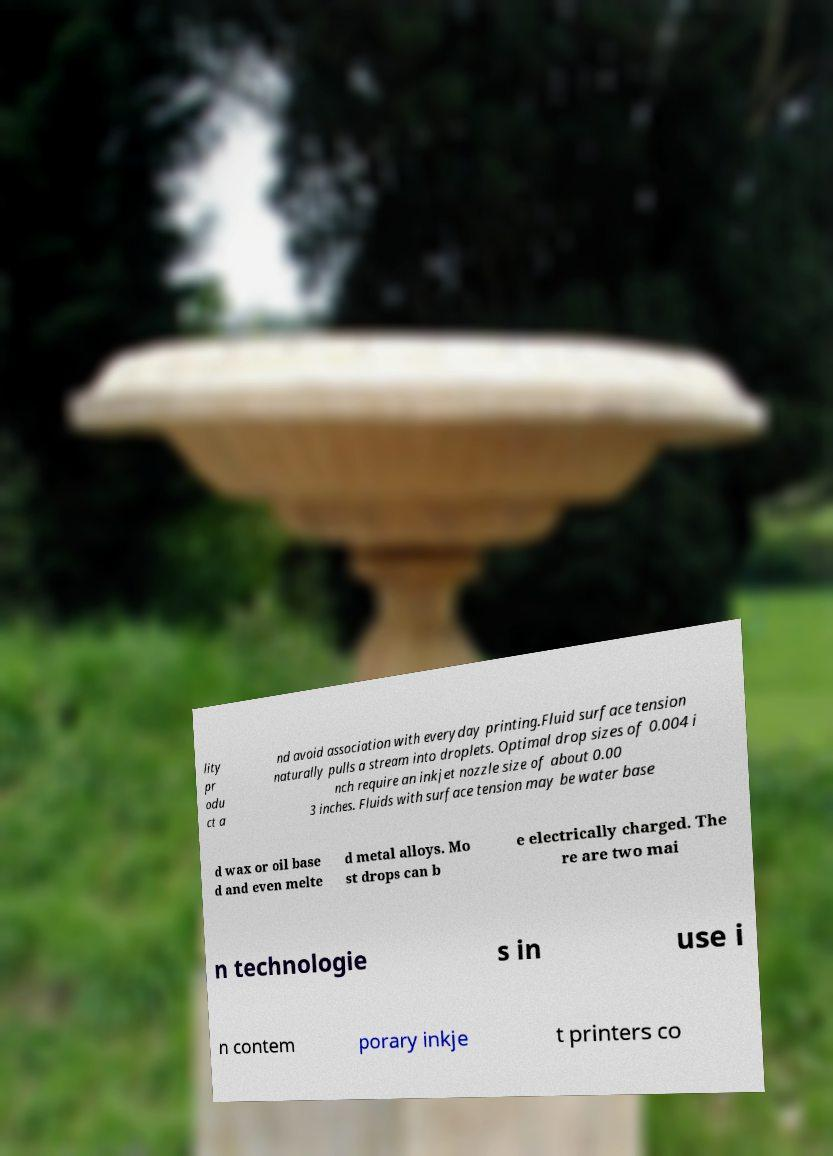I need the written content from this picture converted into text. Can you do that? lity pr odu ct a nd avoid association with everyday printing.Fluid surface tension naturally pulls a stream into droplets. Optimal drop sizes of 0.004 i nch require an inkjet nozzle size of about 0.00 3 inches. Fluids with surface tension may be water base d wax or oil base d and even melte d metal alloys. Mo st drops can b e electrically charged. The re are two mai n technologie s in use i n contem porary inkje t printers co 